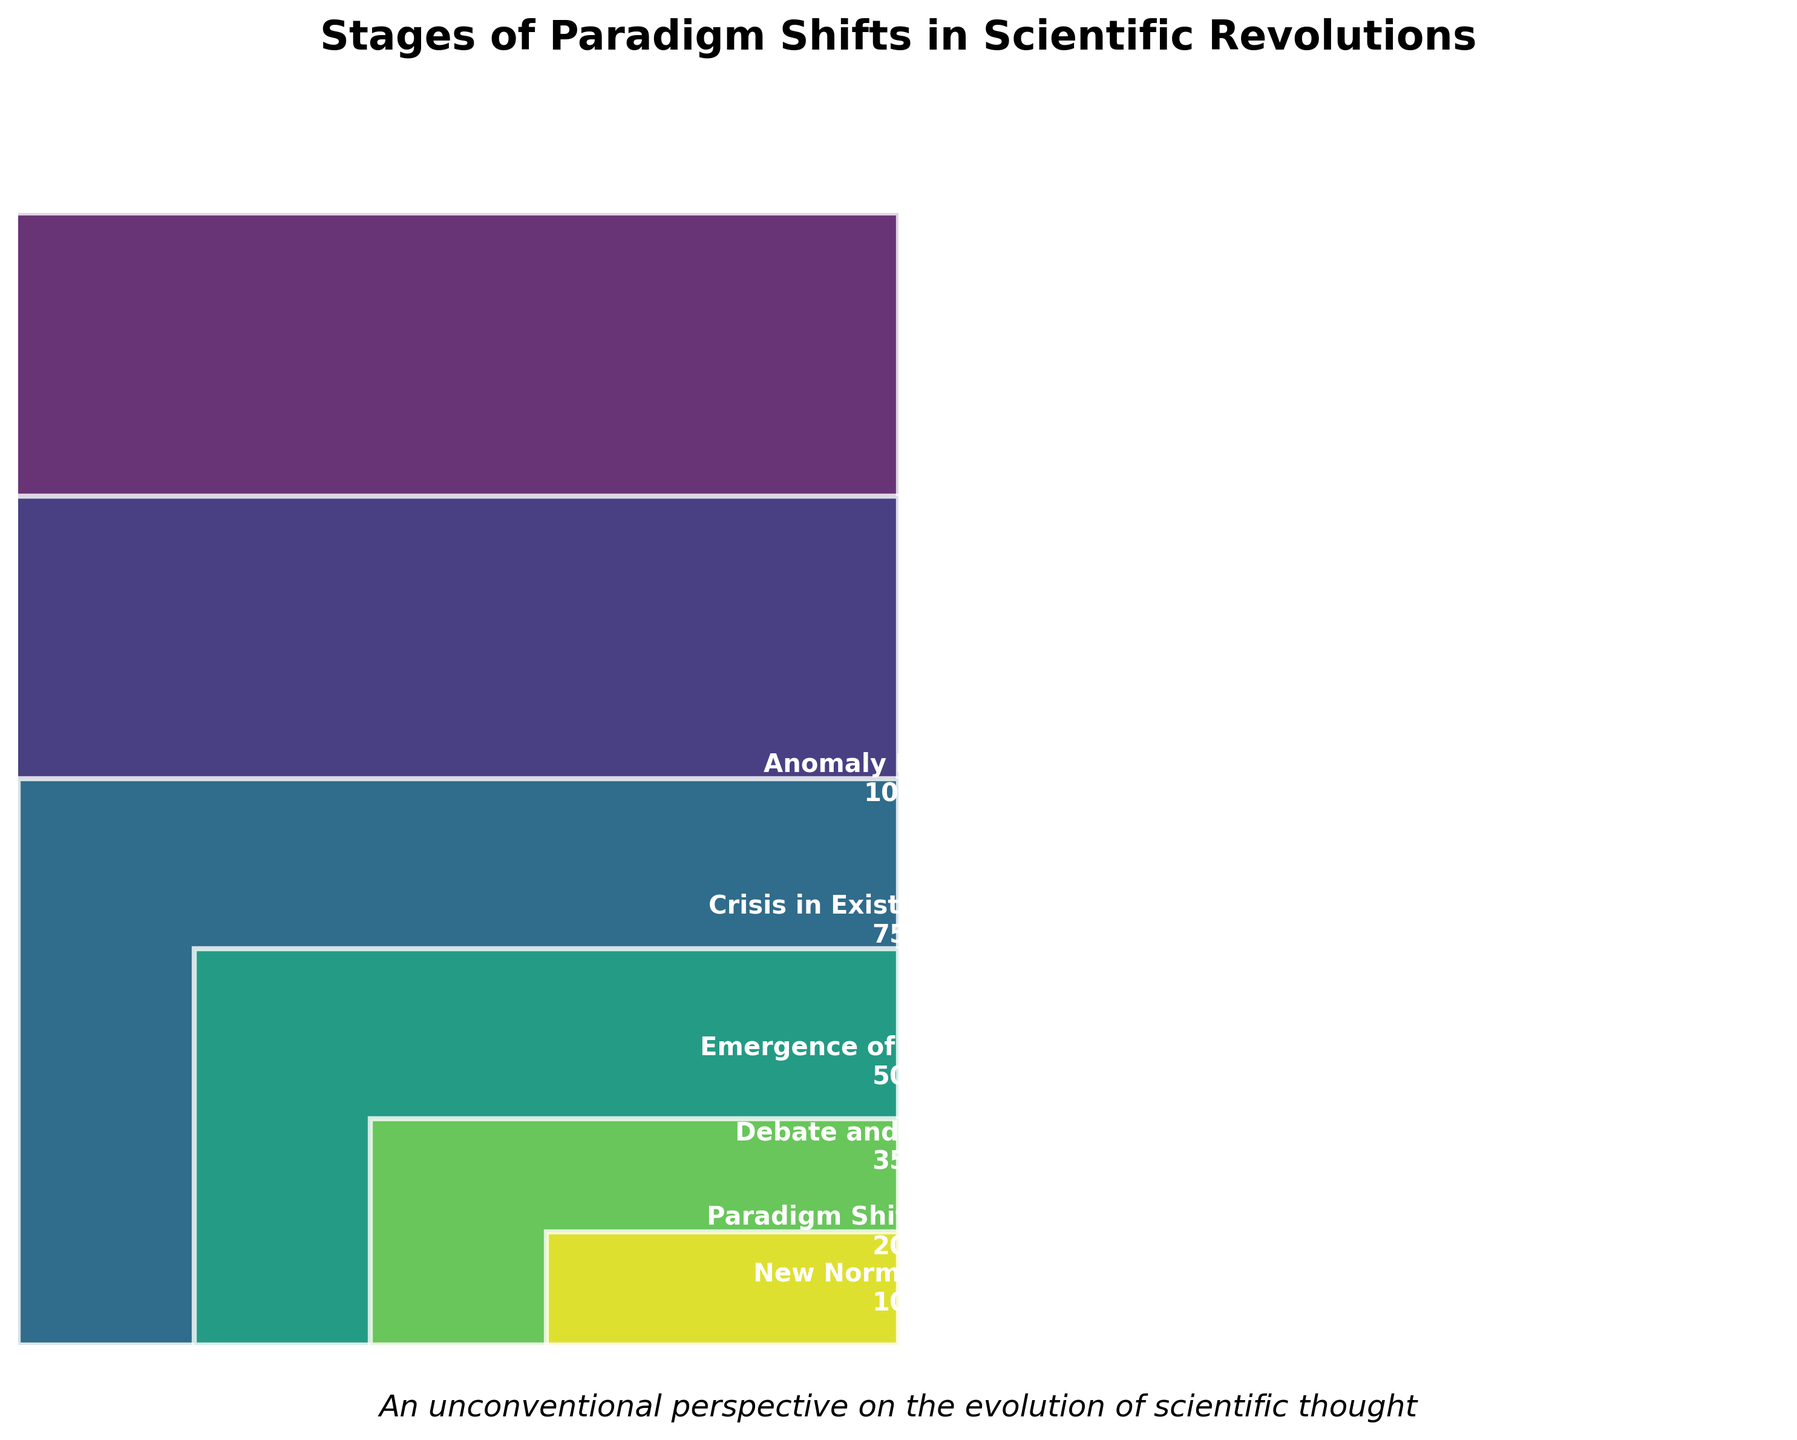What is the title of the figure? The title is printed at the top of the figure, clearly stating the main topic.
Answer: Stages of Paradigm Shifts in Scientific Revolutions How many scientists are at the 'Debate and Resistance' stage? The number of scientists for each stage is marked in the bars, clearly labeled in the 'Debate and Resistance' stage.
Answer: 350 Which stage has the fewest scientists? By comparing the height of all bars and reading the labels, we see the stage with the smallest value.
Answer: New Normal Science How many stages are represented in the funnel chart? Count the distinct bars in the funnel chart.
Answer: 6 What is the difference in the number of scientists between 'Crisis in Existing Paradigm' and 'Emergence of New Theories'? Subtract the number of scientists in 'Emergence of New Theories' from those in 'Crisis in Existing Paradigm' (750 - 500).
Answer: 250 Which stages have more than 500 scientists? Identify and count the bars exceeding the 500 mark.
Answer: Anomaly Detection, Crisis in Existing Paradigm What's the average number of scientists across all stages? Sum the number of scientists and divide by the number of stages: (1000 + 750 + 500 + 350 + 200 + 100) / 6 = 3166 / 6.
Answer: 527.67 Compare the number of scientists in 'Anomaly Detection' and 'New Normal Science': How many times larger is the former? Divide the number of scientists in 'Anomaly Detection' by that in 'New Normal Science' (1000 / 100).
Answer: 10 times Describe the trend shown in the funnel chart. Observing from the top to the bottom, the bars gradually decrease, representing a declining number of scientists as stages advance.
Answer: The number of scientists decreases significantly as stages progress What is the total number of scientists accounted for in the funnel chart? Add up the number of scientists in all stages (1000 + 750 + 500 + 350 + 200 + 100).
Answer: 2900 